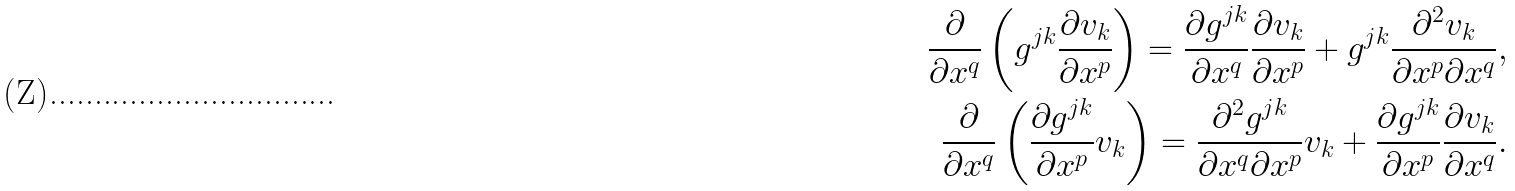Convert formula to latex. <formula><loc_0><loc_0><loc_500><loc_500>\frac { \partial } { \partial x ^ { q } } \left ( g ^ { j k } \frac { \partial v _ { k } } { \partial x ^ { p } } \right ) = \frac { \partial g ^ { j k } } { \partial x ^ { q } } \frac { \partial v _ { k } } { \partial x ^ { p } } + g ^ { j k } \frac { \partial ^ { 2 } v _ { k } } { \partial x ^ { p } \partial x ^ { q } } , \\ \frac { \partial } { \partial x ^ { q } } \left ( \frac { \partial g ^ { j k } } { \partial x ^ { p } } v _ { k } \right ) = \frac { \partial ^ { 2 } g ^ { j k } } { \partial x ^ { q } \partial x ^ { p } } v _ { k } + \frac { \partial g ^ { j k } } { \partial x ^ { p } } \frac { \partial v _ { k } } { \partial x ^ { q } } .</formula> 